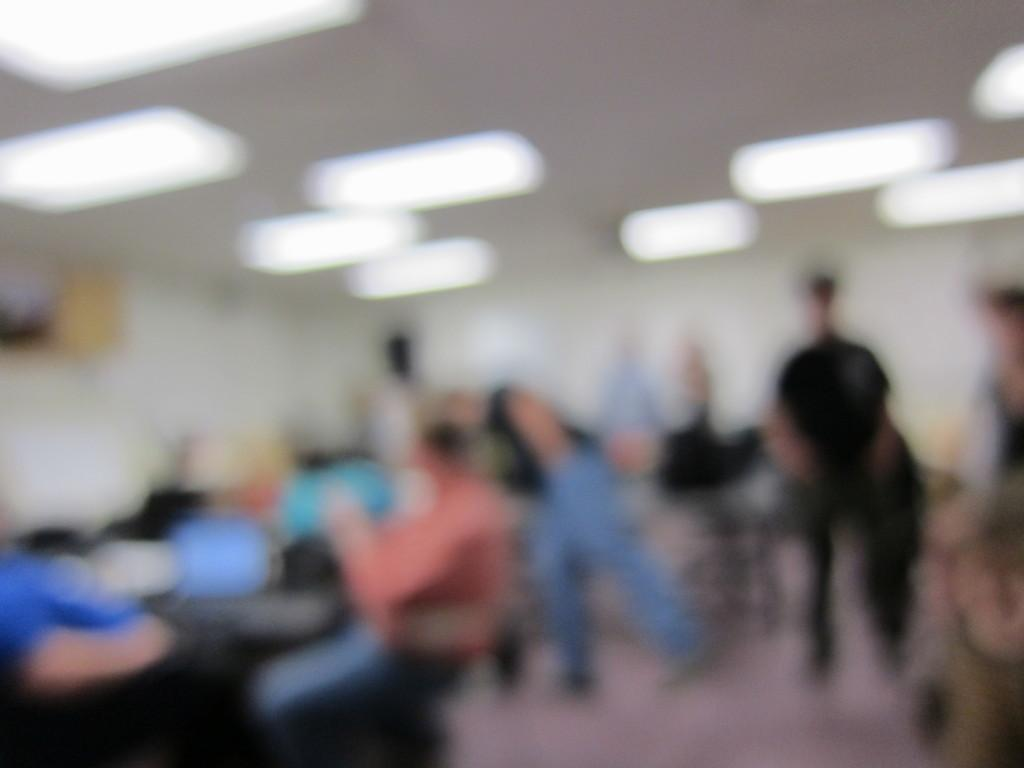What is the overall quality of the image? The image is blurry. Can you identify any subjects in the image? Yes, there are people visible in the image. What is located at the top of the image? There are lights at the top of the image. What type of card is being used by the person in the image? There is no card visible in the image; it is blurry and only shows people and lights. Can you see a rifle in the image? No, there is no rifle present in the image. 